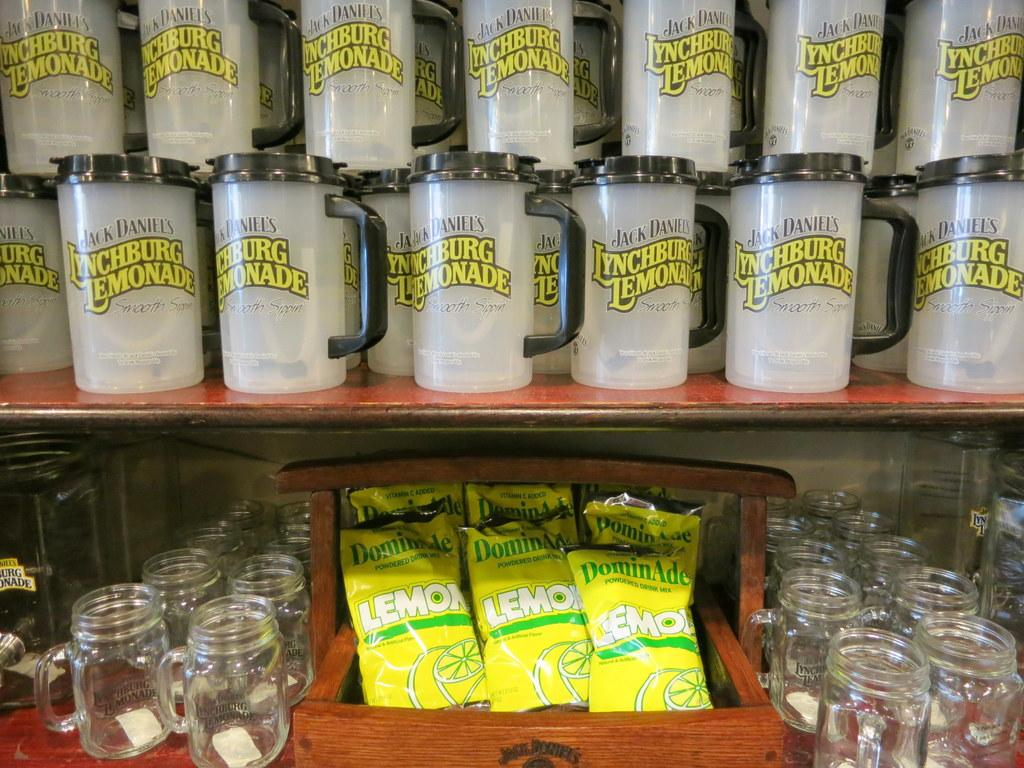<image>
Summarize the visual content of the image. Many plastic mugs that say Lynchburg Lemonade in a store. 